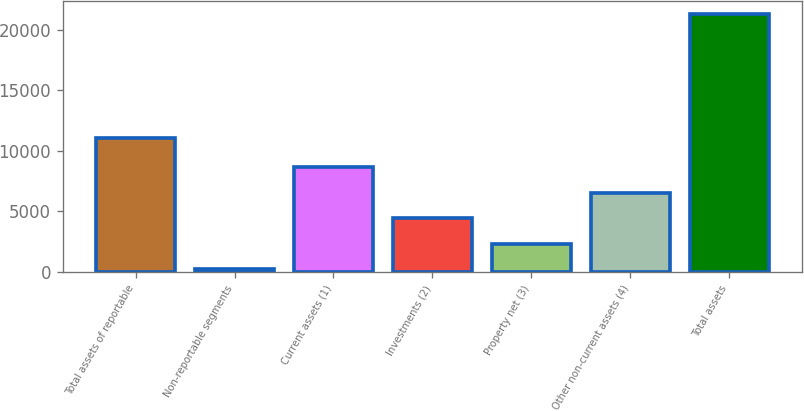Convert chart to OTSL. <chart><loc_0><loc_0><loc_500><loc_500><bar_chart><fcel>Total assets of reportable<fcel>Non-reportable segments<fcel>Current assets (1)<fcel>Investments (2)<fcel>Property net (3)<fcel>Other non-current assets (4)<fcel>Total assets<nl><fcel>11088<fcel>206<fcel>8641.6<fcel>4423.8<fcel>2314.9<fcel>6532.7<fcel>21295<nl></chart> 